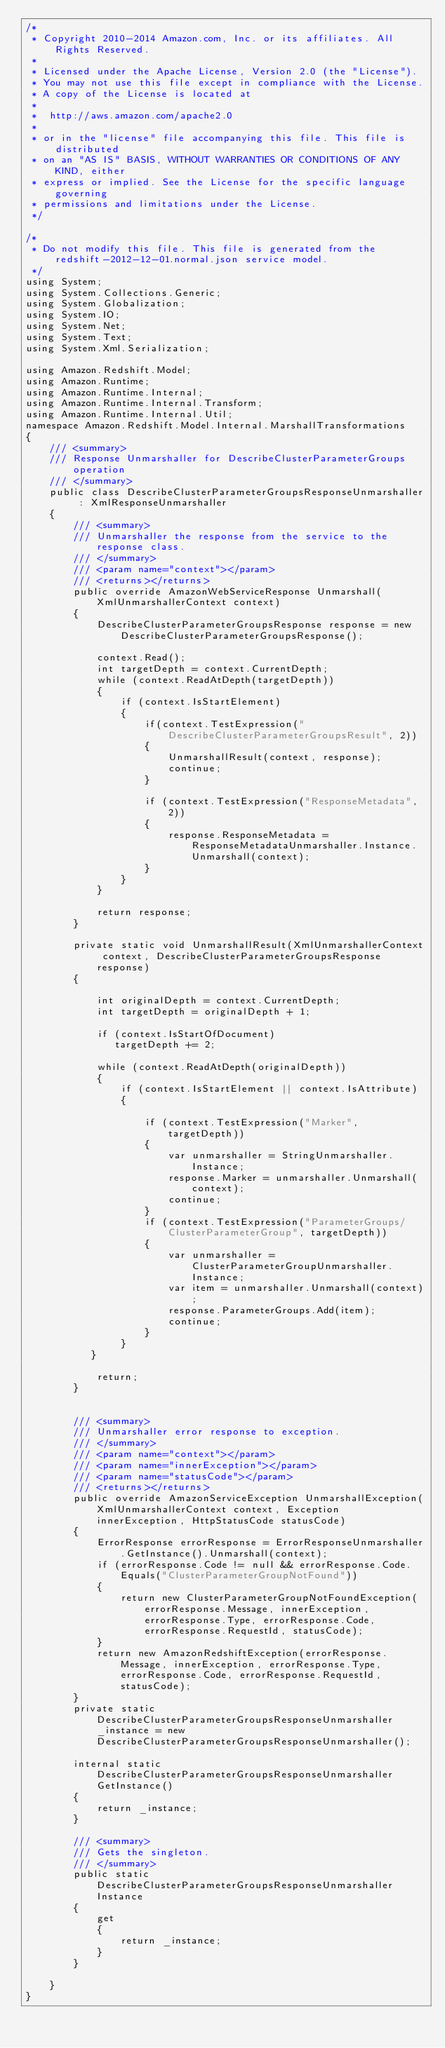Convert code to text. <code><loc_0><loc_0><loc_500><loc_500><_C#_>/*
 * Copyright 2010-2014 Amazon.com, Inc. or its affiliates. All Rights Reserved.
 * 
 * Licensed under the Apache License, Version 2.0 (the "License").
 * You may not use this file except in compliance with the License.
 * A copy of the License is located at
 * 
 *  http://aws.amazon.com/apache2.0
 * 
 * or in the "license" file accompanying this file. This file is distributed
 * on an "AS IS" BASIS, WITHOUT WARRANTIES OR CONDITIONS OF ANY KIND, either
 * express or implied. See the License for the specific language governing
 * permissions and limitations under the License.
 */

/*
 * Do not modify this file. This file is generated from the redshift-2012-12-01.normal.json service model.
 */
using System;
using System.Collections.Generic;
using System.Globalization;
using System.IO;
using System.Net;
using System.Text;
using System.Xml.Serialization;

using Amazon.Redshift.Model;
using Amazon.Runtime;
using Amazon.Runtime.Internal;
using Amazon.Runtime.Internal.Transform;
using Amazon.Runtime.Internal.Util;
namespace Amazon.Redshift.Model.Internal.MarshallTransformations
{
    /// <summary>
    /// Response Unmarshaller for DescribeClusterParameterGroups operation
    /// </summary>  
    public class DescribeClusterParameterGroupsResponseUnmarshaller : XmlResponseUnmarshaller
    {
        /// <summary>
        /// Unmarshaller the response from the service to the response class.
        /// </summary>  
        /// <param name="context"></param>
        /// <returns></returns>
        public override AmazonWebServiceResponse Unmarshall(XmlUnmarshallerContext context)
        {
            DescribeClusterParameterGroupsResponse response = new DescribeClusterParameterGroupsResponse();

            context.Read();
            int targetDepth = context.CurrentDepth;
            while (context.ReadAtDepth(targetDepth))
            {
                if (context.IsStartElement)
                {                    
                    if(context.TestExpression("DescribeClusterParameterGroupsResult", 2))
                    {
                        UnmarshallResult(context, response);                        
                        continue;
                    }
                    
                    if (context.TestExpression("ResponseMetadata", 2))
                    {
                        response.ResponseMetadata = ResponseMetadataUnmarshaller.Instance.Unmarshall(context);
                    }
                }
            }

            return response;
        }

        private static void UnmarshallResult(XmlUnmarshallerContext context, DescribeClusterParameterGroupsResponse response)
        {
            
            int originalDepth = context.CurrentDepth;
            int targetDepth = originalDepth + 1;
            
            if (context.IsStartOfDocument) 
               targetDepth += 2;
            
            while (context.ReadAtDepth(originalDepth))
            {
                if (context.IsStartElement || context.IsAttribute)
                {

                    if (context.TestExpression("Marker", targetDepth))
                    {
                        var unmarshaller = StringUnmarshaller.Instance;
                        response.Marker = unmarshaller.Unmarshall(context);
                        continue;
                    }
                    if (context.TestExpression("ParameterGroups/ClusterParameterGroup", targetDepth))
                    {
                        var unmarshaller = ClusterParameterGroupUnmarshaller.Instance;
                        var item = unmarshaller.Unmarshall(context);
                        response.ParameterGroups.Add(item);
                        continue;
                    }
                } 
           }

            return;
        }


        /// <summary>
        /// Unmarshaller error response to exception.
        /// </summary>  
        /// <param name="context"></param>
        /// <param name="innerException"></param>
        /// <param name="statusCode"></param>
        /// <returns></returns>
        public override AmazonServiceException UnmarshallException(XmlUnmarshallerContext context, Exception innerException, HttpStatusCode statusCode)
        {
            ErrorResponse errorResponse = ErrorResponseUnmarshaller.GetInstance().Unmarshall(context);
            if (errorResponse.Code != null && errorResponse.Code.Equals("ClusterParameterGroupNotFound"))
            {
                return new ClusterParameterGroupNotFoundException(errorResponse.Message, innerException, errorResponse.Type, errorResponse.Code, errorResponse.RequestId, statusCode);
            }
            return new AmazonRedshiftException(errorResponse.Message, innerException, errorResponse.Type, errorResponse.Code, errorResponse.RequestId, statusCode);
        }
        private static DescribeClusterParameterGroupsResponseUnmarshaller _instance = new DescribeClusterParameterGroupsResponseUnmarshaller();        

        internal static DescribeClusterParameterGroupsResponseUnmarshaller GetInstance()
        {
            return _instance;
        }

        /// <summary>
        /// Gets the singleton.
        /// </summary>  
        public static DescribeClusterParameterGroupsResponseUnmarshaller Instance
        {
            get
            {
                return _instance;
            }
        }

    }
}</code> 